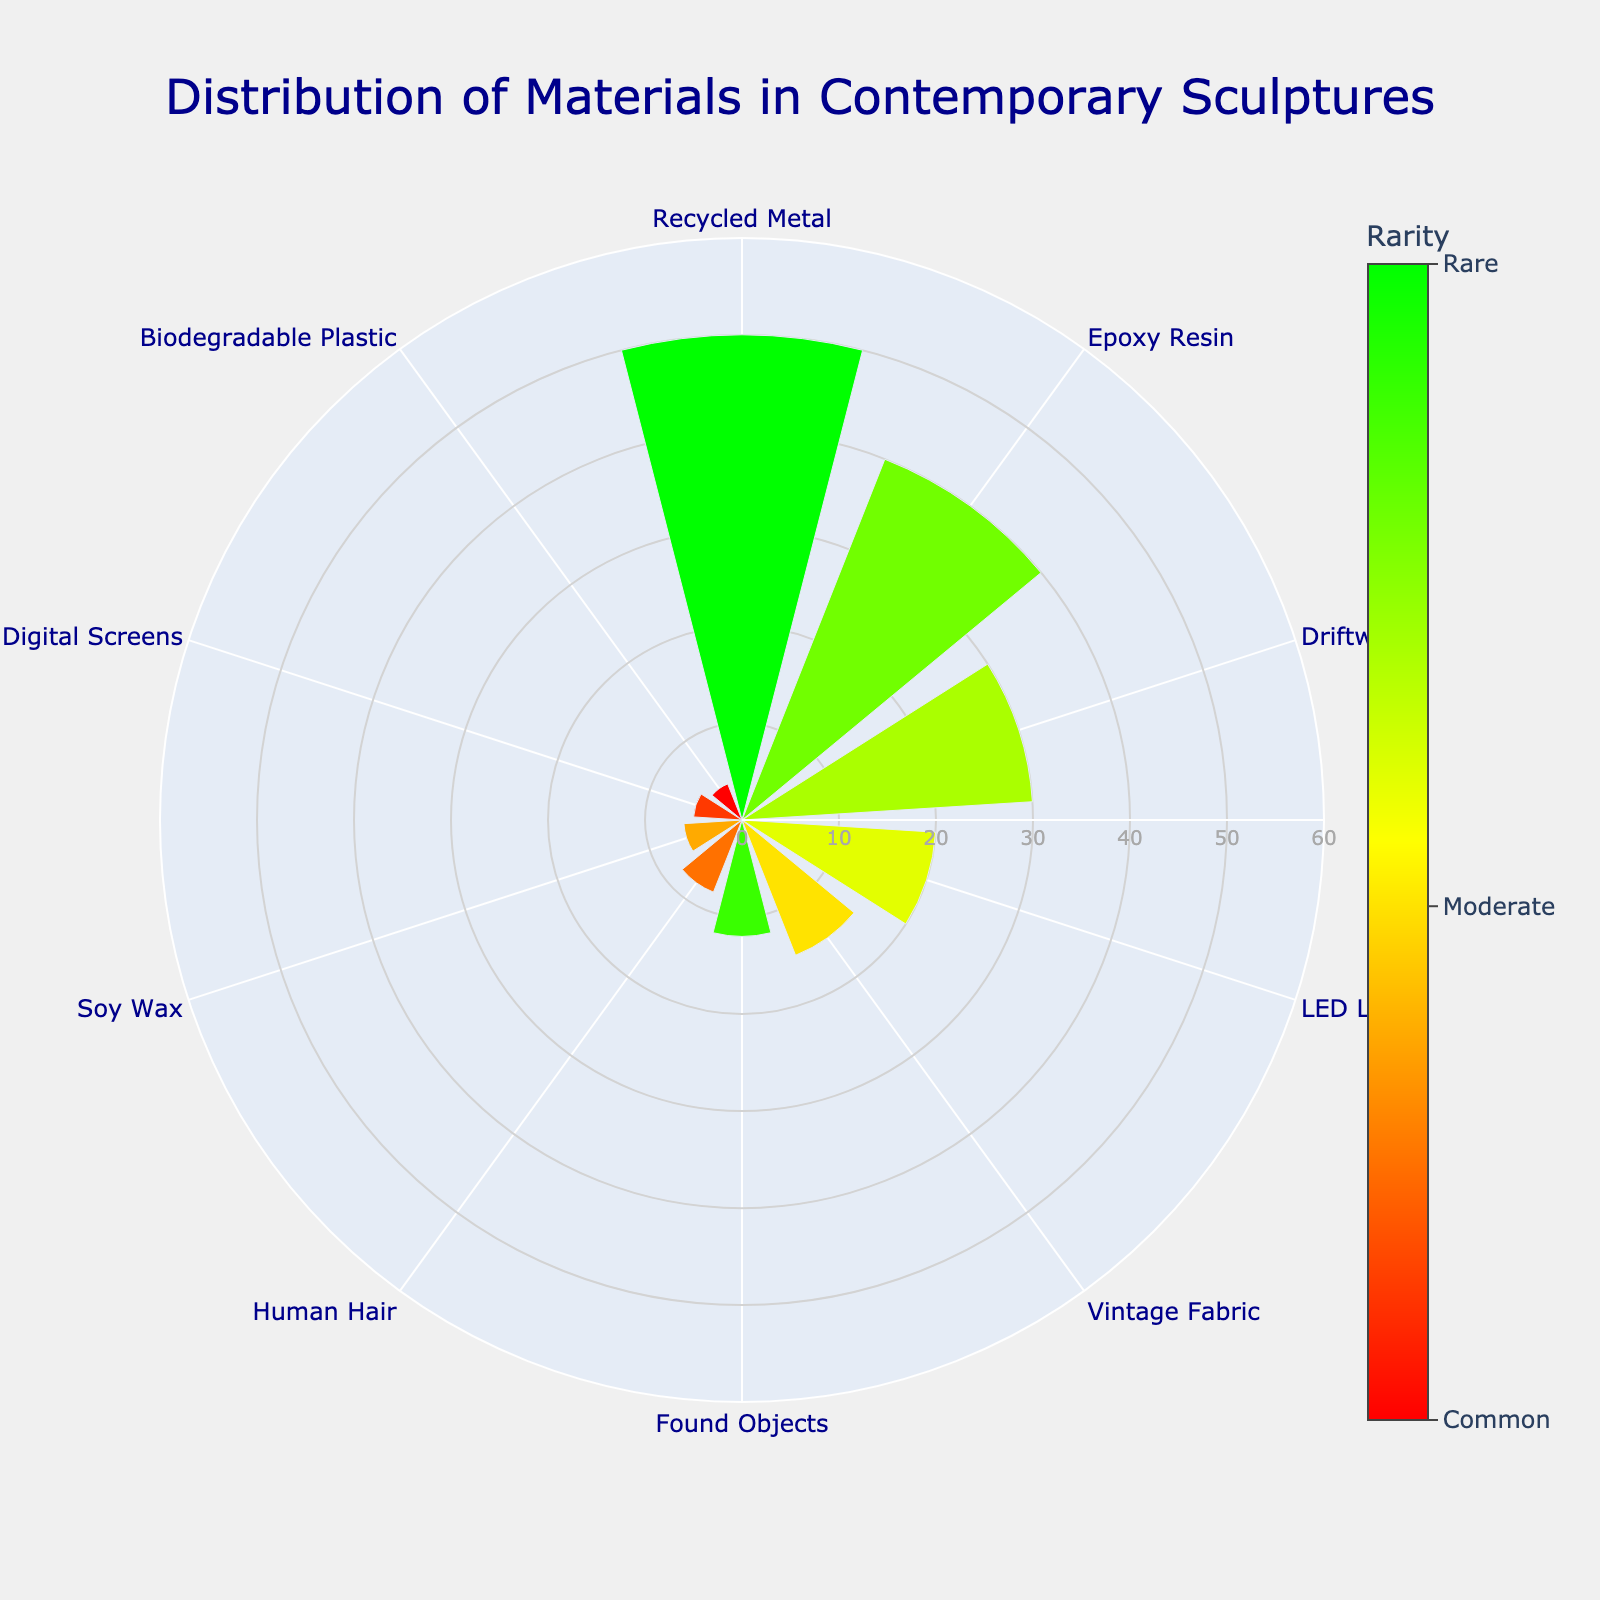How many materials are displayed in the chart? Count the number of distinct segments in the polar area chart.
Answer: 10 Which material has the highest frequency? Identify the segment with the longest radial length indicating the highest frequency.
Answer: Recycled Metal What is the title of the chart? Read the text at the top of the chart which is often the title.
Answer: Distribution of Materials in Contemporary Sculptures Which material has a rarity closest to "Moderate"? Look at the color spectrum and find the material corresponding to the color around the middle rarity on the color bar.
Answer: LED Lights What is the sum of the frequencies of Epoxy Resin and Driftwood? Find the frequencies of Epoxy Resin (40) and Driftwood (30), then add them together: 40 + 30 = 70
Answer: 70 Which material is more common, Human Hair or Biodegradable Plastic? Compare the radial lengths of the segments for Human Hair and Biodegradable Plastic to see which is longer.
Answer: Human Hair What is the average frequency of all materials? Sum up all the frequency values and divide by the number of materials: (50+40+30+20+15+12+8+6+5+4)/10 = 19
Answer: 19 Compare the frequency of LED Lights to Vintage Fabric, which one is higher, and by how much? Find the frequencies of LED Lights (20) and Vintage Fabric (15), then calculate the difference: 20 - 15 = 5
Answer: LED Lights, 5 How is the rarity represented in this chart? The color of each segment varies, representing different levels of rarity as indicated by the color bar (green for more common, red for rarer).
Answer: Colors Which material is the least frequent and what is its rarity? Identify the segment with the shortest radial length indicating the lowest frequency, and check its color against the rarity bar.
Answer: Biodegradable Plastic, 1 